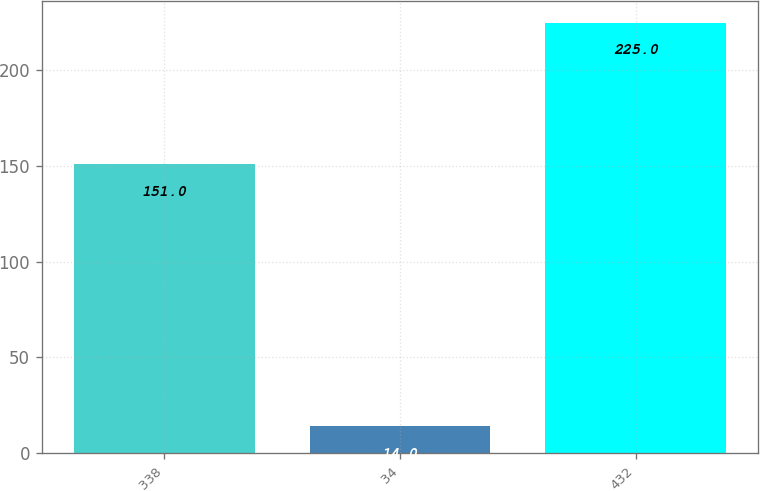Convert chart. <chart><loc_0><loc_0><loc_500><loc_500><bar_chart><fcel>338<fcel>34<fcel>432<nl><fcel>151<fcel>14<fcel>225<nl></chart> 